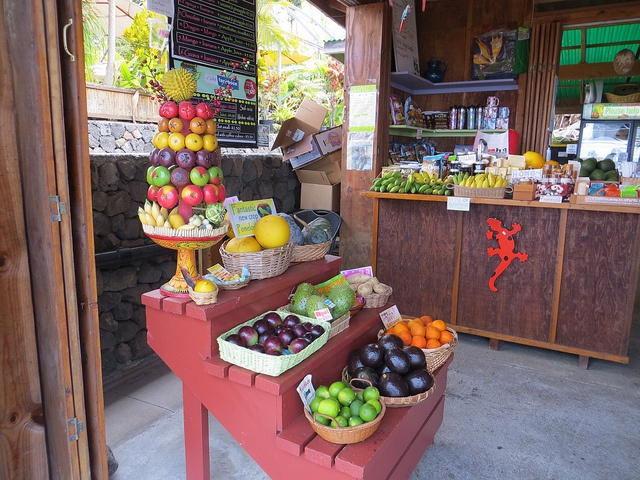Describe the objects in this image and their specific colors. I can see apple in brown, black, purple, and gray tones, orange in brown, red, and orange tones, banana in brown, darkgreen, and olive tones, orange in brown, gold, and olive tones, and apple in brown and salmon tones in this image. 